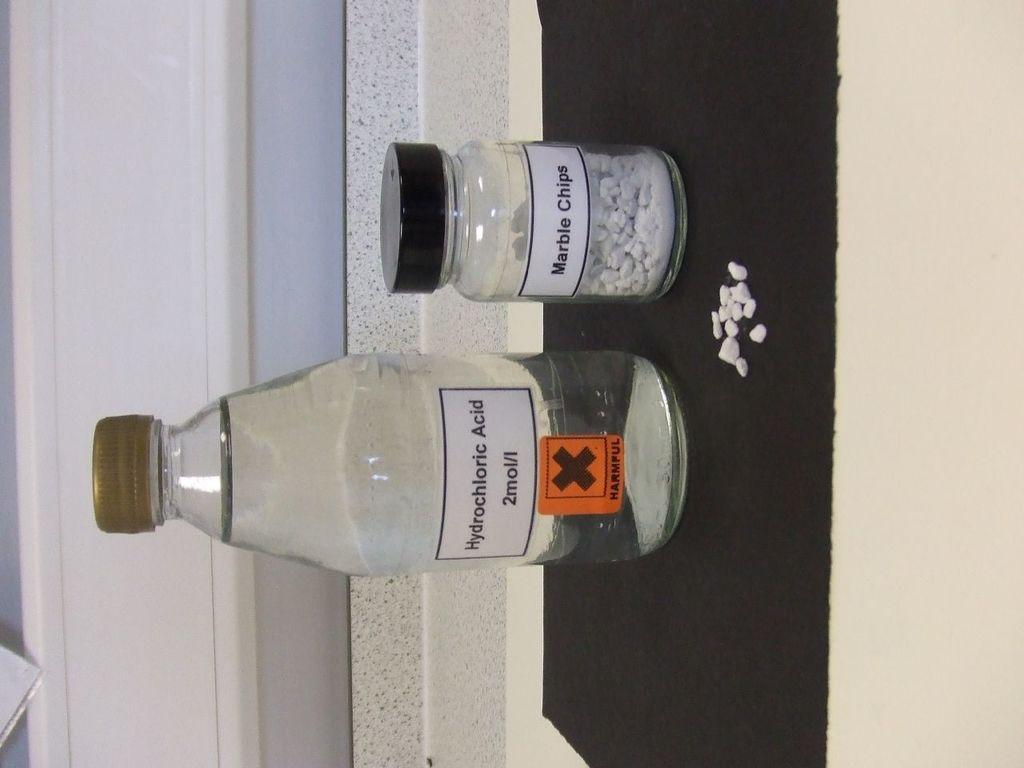Describe this image in one or two sentences. It's a bottle of Hydrochloric acid beside it. It's a glass jar. 